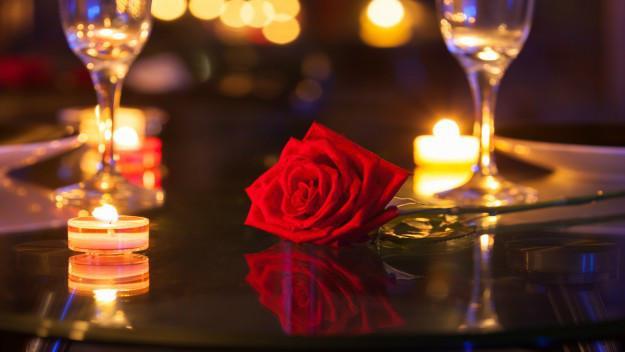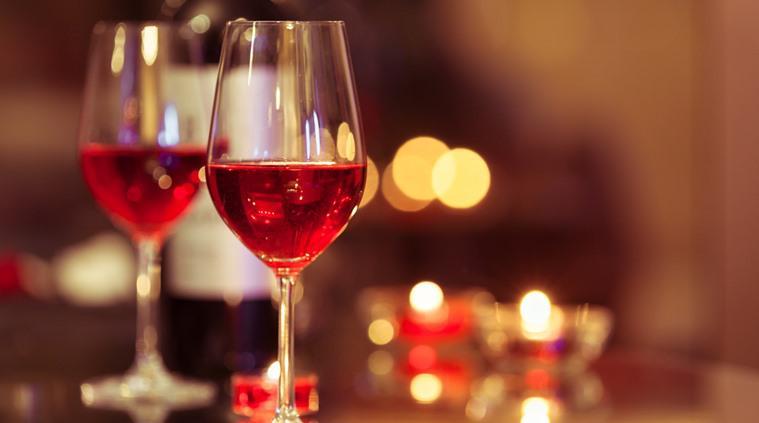The first image is the image on the left, the second image is the image on the right. For the images shown, is this caption "At least one image has a flame or candle in the background." true? Answer yes or no. Yes. The first image is the image on the left, the second image is the image on the right. Evaluate the accuracy of this statement regarding the images: "No hands are holding the wine glasses in the right-hand image.". Is it true? Answer yes or no. Yes. 